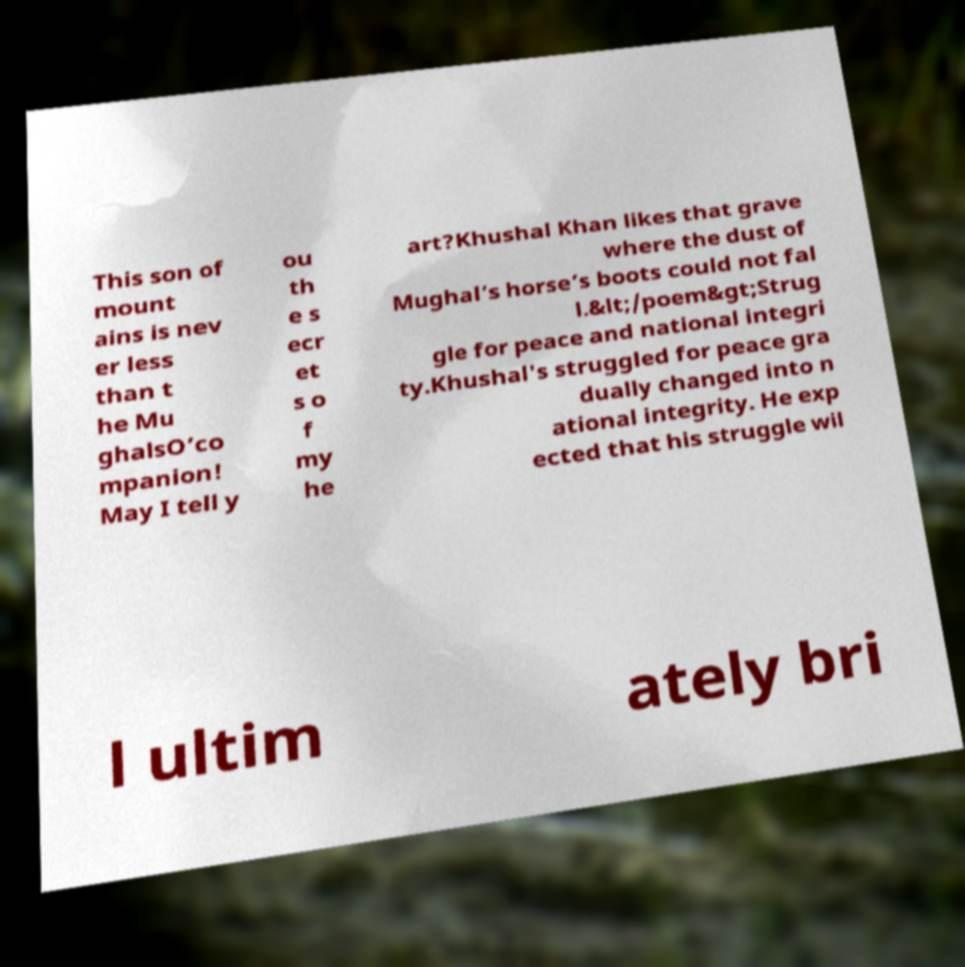Please read and relay the text visible in this image. What does it say? This son of mount ains is nev er less than t he Mu ghalsO’co mpanion! May I tell y ou th e s ecr et s o f my he art?Khushal Khan likes that grave where the dust of Mughal’s horse’s boots could not fal l.&lt;/poem&gt;Strug gle for peace and national integri ty.Khushal's struggled for peace gra dually changed into n ational integrity. He exp ected that his struggle wil l ultim ately bri 